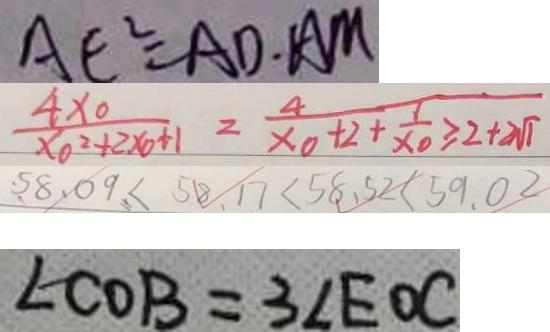<formula> <loc_0><loc_0><loc_500><loc_500>A E ^ { 2 } = A D \cdot A M 
 \frac { 4 x _ { 0 } } { x _ { 0 } ^ { 2 } + 2 x _ { 0 } + 1 } = \frac { 4 } { x _ { 0 } + 2 + \frac { 1 } { x _ { 0 } } \geq 2 + 2 \sqrt { 1 } } 
 5 8 . 0 9 < 5 8 . 1 7 < 5 8 . 5 2 < 5 9 . 0 2 
 \angle C O B = 3 \angle E O C</formula> 